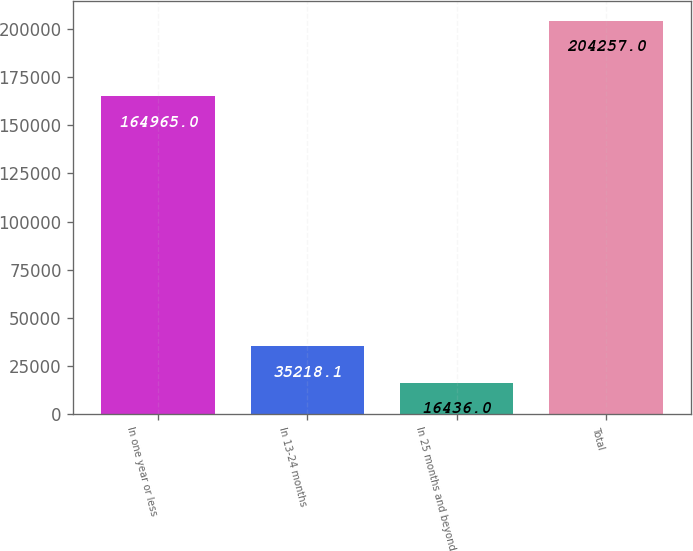Convert chart to OTSL. <chart><loc_0><loc_0><loc_500><loc_500><bar_chart><fcel>In one year or less<fcel>In 13-24 months<fcel>In 25 months and beyond<fcel>Total<nl><fcel>164965<fcel>35218.1<fcel>16436<fcel>204257<nl></chart> 